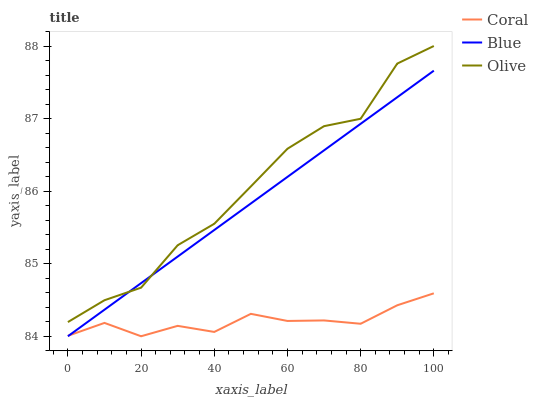Does Coral have the minimum area under the curve?
Answer yes or no. Yes. Does Olive have the maximum area under the curve?
Answer yes or no. Yes. Does Olive have the minimum area under the curve?
Answer yes or no. No. Does Coral have the maximum area under the curve?
Answer yes or no. No. Is Blue the smoothest?
Answer yes or no. Yes. Is Olive the roughest?
Answer yes or no. Yes. Is Coral the smoothest?
Answer yes or no. No. Is Coral the roughest?
Answer yes or no. No. Does Blue have the lowest value?
Answer yes or no. Yes. Does Olive have the lowest value?
Answer yes or no. No. Does Olive have the highest value?
Answer yes or no. Yes. Does Coral have the highest value?
Answer yes or no. No. Is Coral less than Olive?
Answer yes or no. Yes. Is Olive greater than Coral?
Answer yes or no. Yes. Does Blue intersect Coral?
Answer yes or no. Yes. Is Blue less than Coral?
Answer yes or no. No. Is Blue greater than Coral?
Answer yes or no. No. Does Coral intersect Olive?
Answer yes or no. No. 